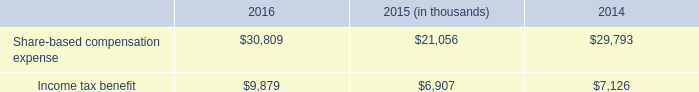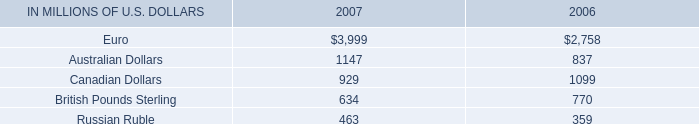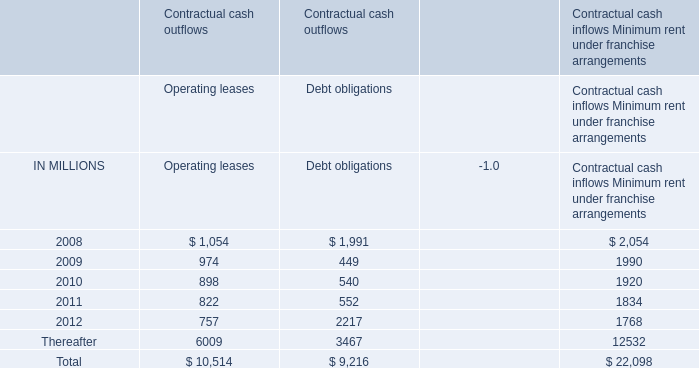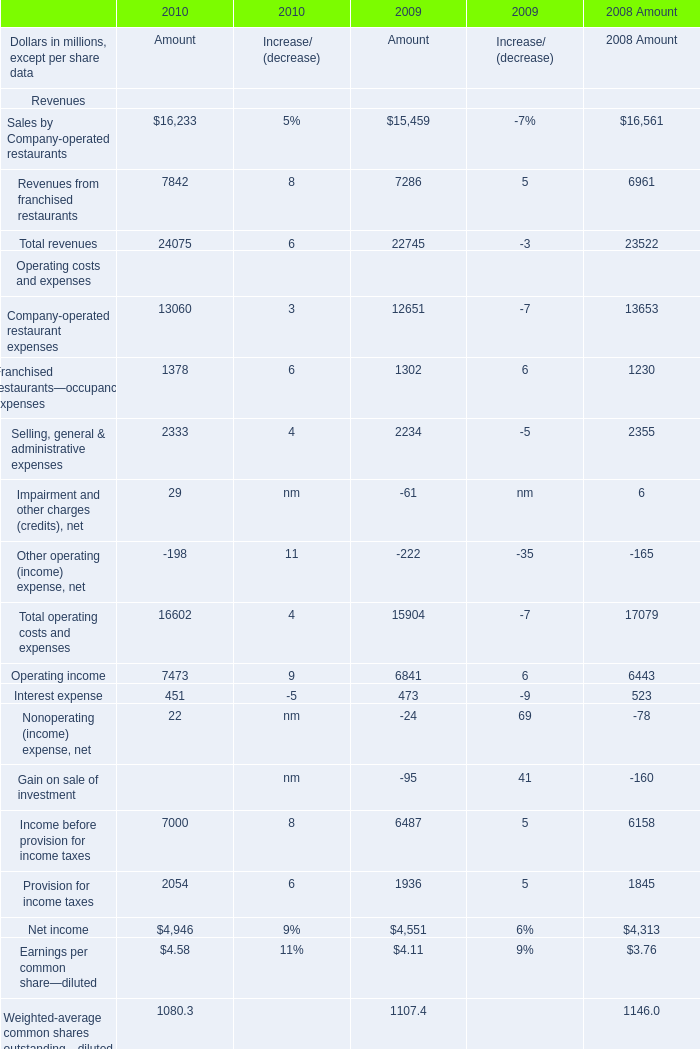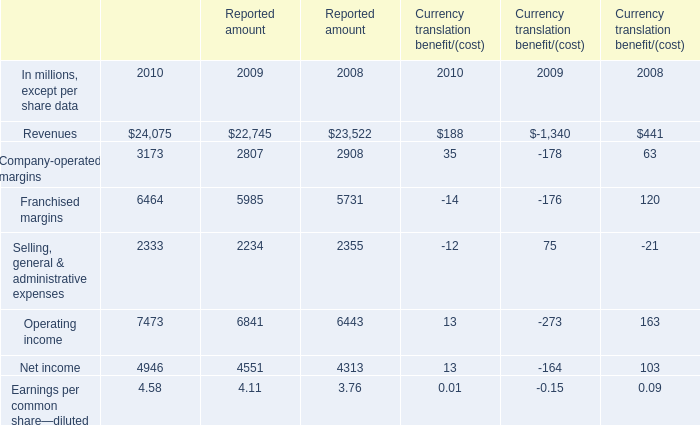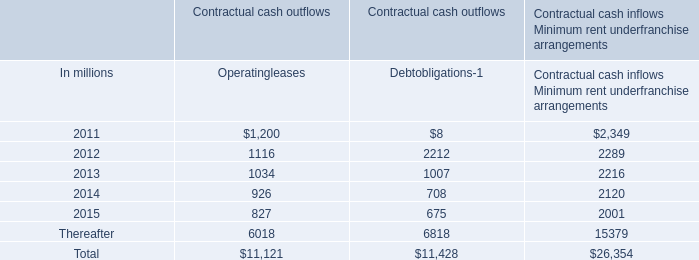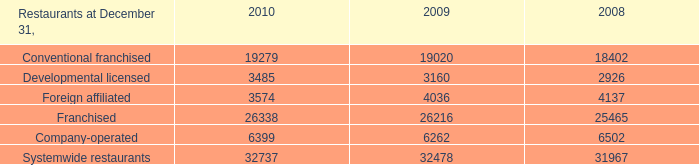What's the sum of all Currency translation benefit/(cost) that are positive in 2010? (in million) 
Computations: ((((35 + 188) + 13) + 13) + 0.01)
Answer: 249.01. 